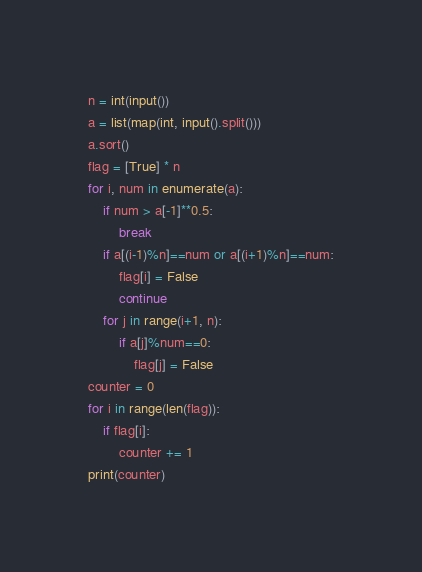Convert code to text. <code><loc_0><loc_0><loc_500><loc_500><_Python_>n = int(input())
a = list(map(int, input().split()))
a.sort()
flag = [True] * n
for i, num in enumerate(a):
    if num > a[-1]**0.5:
        break
    if a[(i-1)%n]==num or a[(i+1)%n]==num:
        flag[i] = False
        continue
    for j in range(i+1, n):
        if a[j]%num==0:
            flag[j] = False
counter = 0
for i in range(len(flag)):
    if flag[i]:
        counter += 1
print(counter)</code> 